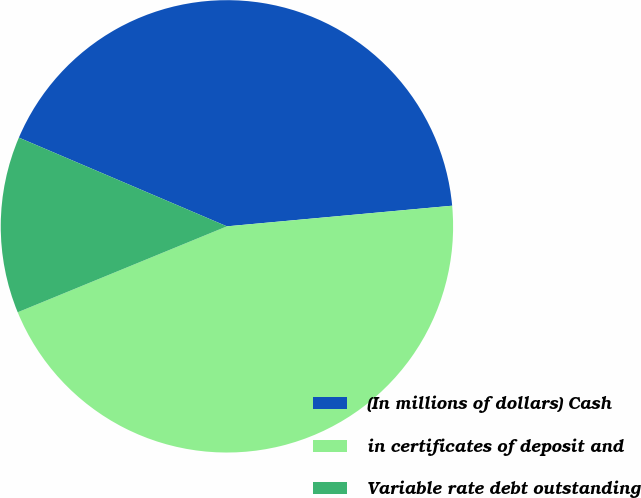Convert chart. <chart><loc_0><loc_0><loc_500><loc_500><pie_chart><fcel>(In millions of dollars) Cash<fcel>in certificates of deposit and<fcel>Variable rate debt outstanding<nl><fcel>42.13%<fcel>45.25%<fcel>12.62%<nl></chart> 